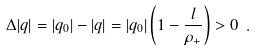<formula> <loc_0><loc_0><loc_500><loc_500>\Delta | q | = | q _ { 0 } | - | q | = | q _ { 0 } | \left ( 1 - \frac { l } { \rho _ { + } } \right ) > 0 \ .</formula> 